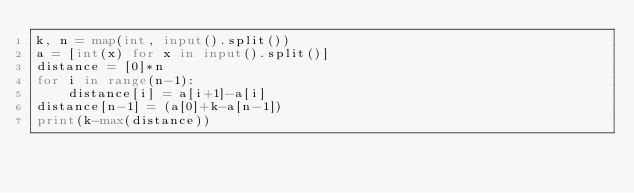<code> <loc_0><loc_0><loc_500><loc_500><_Python_>k, n = map(int, input().split())
a = [int(x) for x in input().split()]
distance = [0]*n
for i in range(n-1):
    distance[i] = a[i+1]-a[i]
distance[n-1] = (a[0]+k-a[n-1])
print(k-max(distance))</code> 